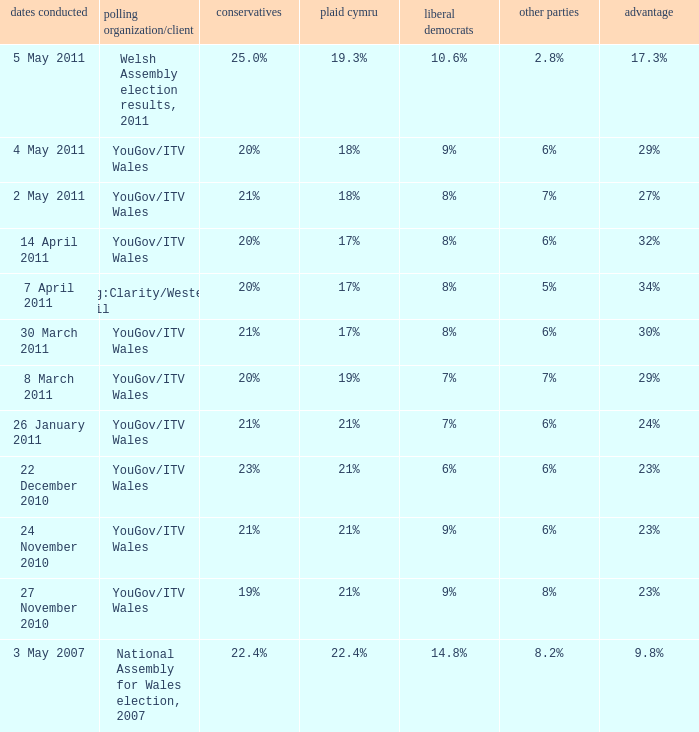I want the lead for others being 5% 34%. 